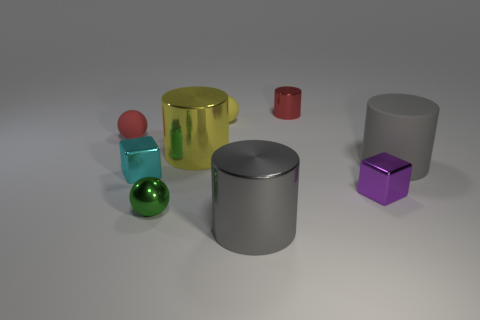Subtract all green cylinders. Subtract all red cubes. How many cylinders are left? 4 Add 1 green objects. How many objects exist? 10 Subtract all balls. How many objects are left? 6 Subtract 1 green spheres. How many objects are left? 8 Subtract all gray matte objects. Subtract all big shiny things. How many objects are left? 6 Add 6 big gray rubber things. How many big gray rubber things are left? 7 Add 2 yellow metal cylinders. How many yellow metal cylinders exist? 3 